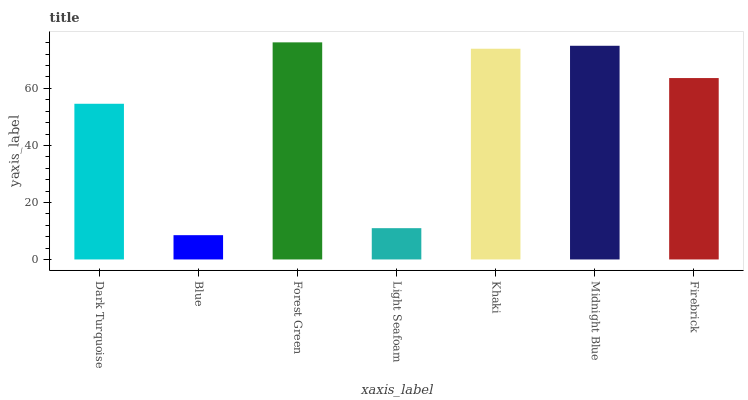Is Forest Green the minimum?
Answer yes or no. No. Is Blue the maximum?
Answer yes or no. No. Is Forest Green greater than Blue?
Answer yes or no. Yes. Is Blue less than Forest Green?
Answer yes or no. Yes. Is Blue greater than Forest Green?
Answer yes or no. No. Is Forest Green less than Blue?
Answer yes or no. No. Is Firebrick the high median?
Answer yes or no. Yes. Is Firebrick the low median?
Answer yes or no. Yes. Is Blue the high median?
Answer yes or no. No. Is Midnight Blue the low median?
Answer yes or no. No. 